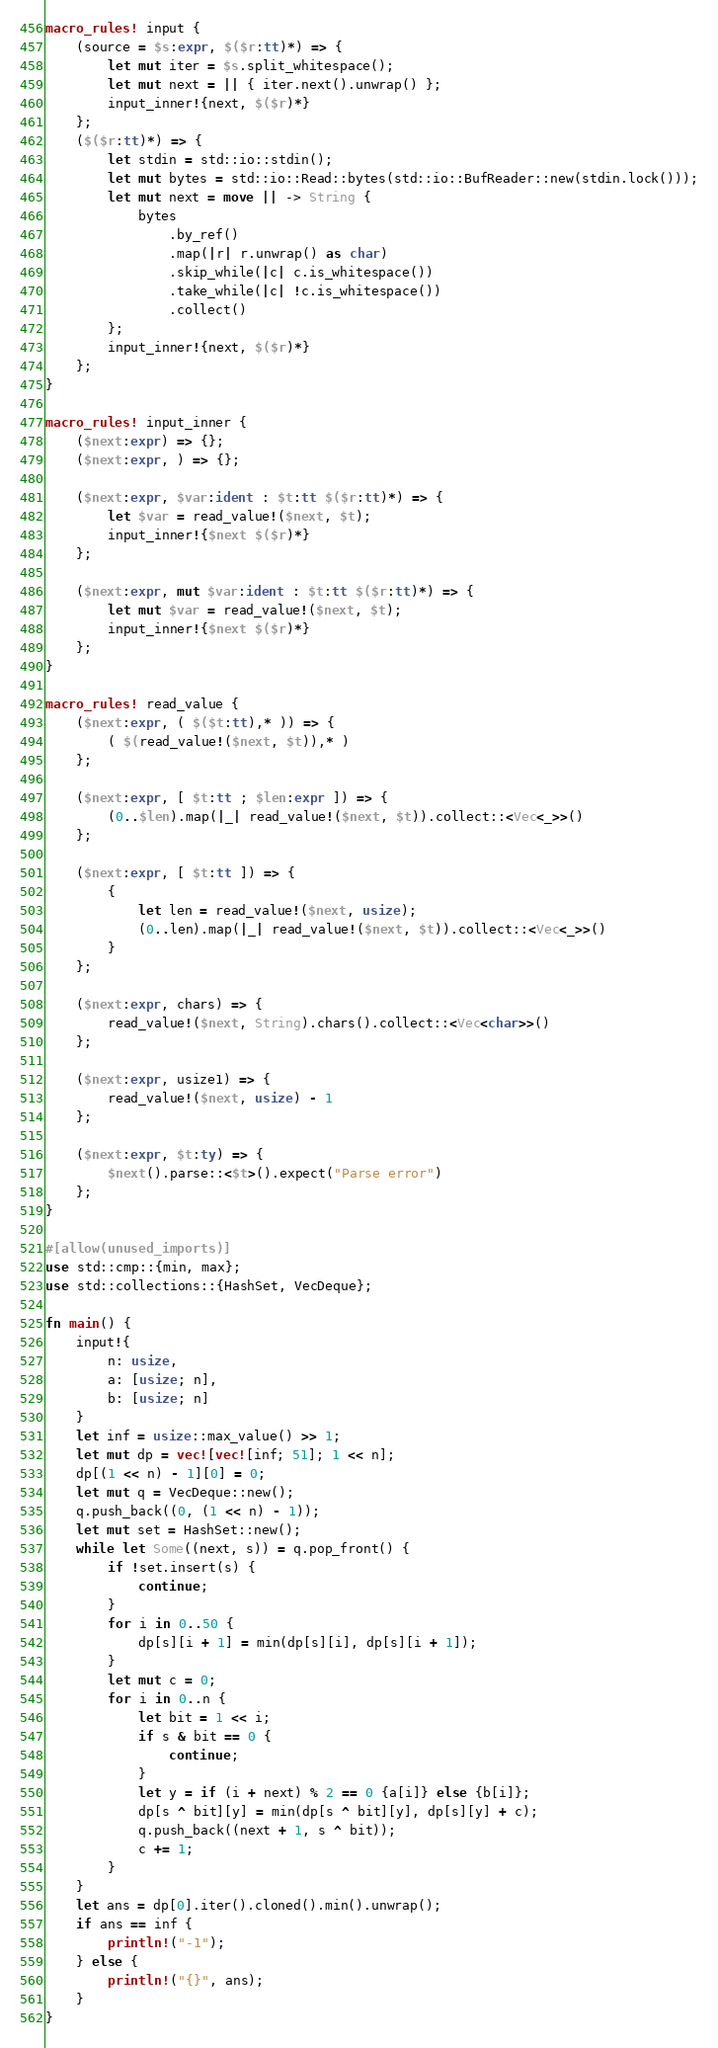<code> <loc_0><loc_0><loc_500><loc_500><_Rust_>macro_rules! input {
    (source = $s:expr, $($r:tt)*) => {
        let mut iter = $s.split_whitespace();
        let mut next = || { iter.next().unwrap() };
        input_inner!{next, $($r)*}
    };
    ($($r:tt)*) => {
        let stdin = std::io::stdin();
        let mut bytes = std::io::Read::bytes(std::io::BufReader::new(stdin.lock()));
        let mut next = move || -> String {
            bytes
                .by_ref()
                .map(|r| r.unwrap() as char)
                .skip_while(|c| c.is_whitespace())
                .take_while(|c| !c.is_whitespace())
                .collect()
        };
        input_inner!{next, $($r)*}
    };
}

macro_rules! input_inner {
    ($next:expr) => {};
    ($next:expr, ) => {};

    ($next:expr, $var:ident : $t:tt $($r:tt)*) => {
        let $var = read_value!($next, $t);
        input_inner!{$next $($r)*}
    };

    ($next:expr, mut $var:ident : $t:tt $($r:tt)*) => {
        let mut $var = read_value!($next, $t);
        input_inner!{$next $($r)*}
    };
}

macro_rules! read_value {
    ($next:expr, ( $($t:tt),* )) => {
        ( $(read_value!($next, $t)),* )
    };

    ($next:expr, [ $t:tt ; $len:expr ]) => {
        (0..$len).map(|_| read_value!($next, $t)).collect::<Vec<_>>()
    };

    ($next:expr, [ $t:tt ]) => {
        {
            let len = read_value!($next, usize);
            (0..len).map(|_| read_value!($next, $t)).collect::<Vec<_>>()
        }
    };

    ($next:expr, chars) => {
        read_value!($next, String).chars().collect::<Vec<char>>()
    };

    ($next:expr, usize1) => {
        read_value!($next, usize) - 1
    };

    ($next:expr, $t:ty) => {
        $next().parse::<$t>().expect("Parse error")
    };
}

#[allow(unused_imports)]
use std::cmp::{min, max};
use std::collections::{HashSet, VecDeque};

fn main() {
    input!{
        n: usize,
        a: [usize; n],
        b: [usize; n]
    }
    let inf = usize::max_value() >> 1;
    let mut dp = vec![vec![inf; 51]; 1 << n];
    dp[(1 << n) - 1][0] = 0;
    let mut q = VecDeque::new();
    q.push_back((0, (1 << n) - 1));
    let mut set = HashSet::new();
    while let Some((next, s)) = q.pop_front() {
        if !set.insert(s) {
            continue;
        }
        for i in 0..50 {
            dp[s][i + 1] = min(dp[s][i], dp[s][i + 1]);
        }
        let mut c = 0;
        for i in 0..n {
            let bit = 1 << i;
            if s & bit == 0 {
                continue;
            }
            let y = if (i + next) % 2 == 0 {a[i]} else {b[i]};
            dp[s ^ bit][y] = min(dp[s ^ bit][y], dp[s][y] + c);
            q.push_back((next + 1, s ^ bit));
            c += 1;
        }
    }
    let ans = dp[0].iter().cloned().min().unwrap();
    if ans == inf {
        println!("-1");
    } else {
        println!("{}", ans);
    }
}
</code> 